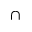Convert formula to latex. <formula><loc_0><loc_0><loc_500><loc_500>\cap</formula> 